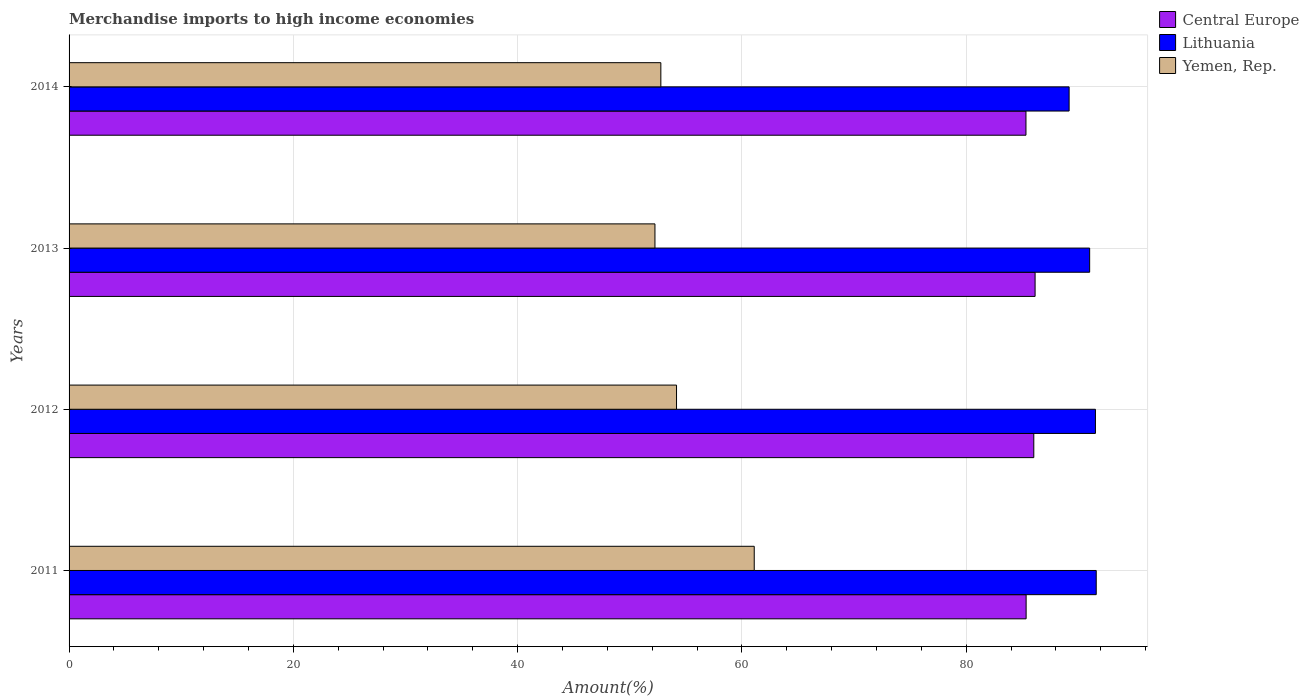How many different coloured bars are there?
Make the answer very short. 3. In how many cases, is the number of bars for a given year not equal to the number of legend labels?
Provide a short and direct response. 0. What is the percentage of amount earned from merchandise imports in Central Europe in 2013?
Your response must be concise. 86.14. Across all years, what is the maximum percentage of amount earned from merchandise imports in Lithuania?
Offer a very short reply. 91.59. Across all years, what is the minimum percentage of amount earned from merchandise imports in Lithuania?
Offer a terse response. 89.18. In which year was the percentage of amount earned from merchandise imports in Lithuania minimum?
Keep it short and to the point. 2014. What is the total percentage of amount earned from merchandise imports in Central Europe in the graph?
Your answer should be very brief. 342.84. What is the difference between the percentage of amount earned from merchandise imports in Yemen, Rep. in 2011 and that in 2012?
Ensure brevity in your answer.  6.93. What is the difference between the percentage of amount earned from merchandise imports in Yemen, Rep. in 2011 and the percentage of amount earned from merchandise imports in Central Europe in 2012?
Your answer should be very brief. -24.93. What is the average percentage of amount earned from merchandise imports in Yemen, Rep. per year?
Your answer should be very brief. 55.07. In the year 2011, what is the difference between the percentage of amount earned from merchandise imports in Yemen, Rep. and percentage of amount earned from merchandise imports in Lithuania?
Keep it short and to the point. -30.5. In how many years, is the percentage of amount earned from merchandise imports in Lithuania greater than 28 %?
Offer a very short reply. 4. What is the ratio of the percentage of amount earned from merchandise imports in Yemen, Rep. in 2012 to that in 2013?
Offer a very short reply. 1.04. What is the difference between the highest and the second highest percentage of amount earned from merchandise imports in Central Europe?
Offer a very short reply. 0.12. What is the difference between the highest and the lowest percentage of amount earned from merchandise imports in Lithuania?
Your answer should be very brief. 2.42. What does the 1st bar from the top in 2013 represents?
Ensure brevity in your answer.  Yemen, Rep. What does the 1st bar from the bottom in 2011 represents?
Your answer should be very brief. Central Europe. Is it the case that in every year, the sum of the percentage of amount earned from merchandise imports in Lithuania and percentage of amount earned from merchandise imports in Yemen, Rep. is greater than the percentage of amount earned from merchandise imports in Central Europe?
Offer a terse response. Yes. Are all the bars in the graph horizontal?
Your answer should be very brief. Yes. How many years are there in the graph?
Give a very brief answer. 4. Does the graph contain grids?
Give a very brief answer. Yes. How many legend labels are there?
Your response must be concise. 3. What is the title of the graph?
Give a very brief answer. Merchandise imports to high income economies. Does "Nicaragua" appear as one of the legend labels in the graph?
Offer a very short reply. No. What is the label or title of the X-axis?
Make the answer very short. Amount(%). What is the label or title of the Y-axis?
Your answer should be very brief. Years. What is the Amount(%) in Central Europe in 2011?
Your answer should be very brief. 85.34. What is the Amount(%) of Lithuania in 2011?
Your answer should be compact. 91.59. What is the Amount(%) in Yemen, Rep. in 2011?
Your answer should be compact. 61.1. What is the Amount(%) in Central Europe in 2012?
Your response must be concise. 86.03. What is the Amount(%) of Lithuania in 2012?
Make the answer very short. 91.52. What is the Amount(%) of Yemen, Rep. in 2012?
Your response must be concise. 54.17. What is the Amount(%) in Central Europe in 2013?
Offer a very short reply. 86.14. What is the Amount(%) in Lithuania in 2013?
Your answer should be compact. 91.01. What is the Amount(%) of Yemen, Rep. in 2013?
Ensure brevity in your answer.  52.24. What is the Amount(%) of Central Europe in 2014?
Provide a short and direct response. 85.33. What is the Amount(%) in Lithuania in 2014?
Your response must be concise. 89.18. What is the Amount(%) of Yemen, Rep. in 2014?
Offer a terse response. 52.77. Across all years, what is the maximum Amount(%) in Central Europe?
Offer a very short reply. 86.14. Across all years, what is the maximum Amount(%) of Lithuania?
Keep it short and to the point. 91.59. Across all years, what is the maximum Amount(%) in Yemen, Rep.?
Your response must be concise. 61.1. Across all years, what is the minimum Amount(%) of Central Europe?
Your answer should be compact. 85.33. Across all years, what is the minimum Amount(%) of Lithuania?
Your response must be concise. 89.18. Across all years, what is the minimum Amount(%) in Yemen, Rep.?
Offer a very short reply. 52.24. What is the total Amount(%) of Central Europe in the graph?
Give a very brief answer. 342.84. What is the total Amount(%) of Lithuania in the graph?
Keep it short and to the point. 363.3. What is the total Amount(%) in Yemen, Rep. in the graph?
Ensure brevity in your answer.  220.28. What is the difference between the Amount(%) of Central Europe in 2011 and that in 2012?
Offer a very short reply. -0.68. What is the difference between the Amount(%) in Lithuania in 2011 and that in 2012?
Offer a terse response. 0.07. What is the difference between the Amount(%) of Yemen, Rep. in 2011 and that in 2012?
Your response must be concise. 6.93. What is the difference between the Amount(%) of Central Europe in 2011 and that in 2013?
Offer a very short reply. -0.8. What is the difference between the Amount(%) in Lithuania in 2011 and that in 2013?
Offer a terse response. 0.59. What is the difference between the Amount(%) of Yemen, Rep. in 2011 and that in 2013?
Give a very brief answer. 8.85. What is the difference between the Amount(%) of Central Europe in 2011 and that in 2014?
Provide a succinct answer. 0.01. What is the difference between the Amount(%) of Lithuania in 2011 and that in 2014?
Make the answer very short. 2.42. What is the difference between the Amount(%) in Yemen, Rep. in 2011 and that in 2014?
Ensure brevity in your answer.  8.33. What is the difference between the Amount(%) in Central Europe in 2012 and that in 2013?
Ensure brevity in your answer.  -0.12. What is the difference between the Amount(%) in Lithuania in 2012 and that in 2013?
Your response must be concise. 0.51. What is the difference between the Amount(%) of Yemen, Rep. in 2012 and that in 2013?
Offer a terse response. 1.92. What is the difference between the Amount(%) of Central Europe in 2012 and that in 2014?
Your response must be concise. 0.7. What is the difference between the Amount(%) in Lithuania in 2012 and that in 2014?
Make the answer very short. 2.35. What is the difference between the Amount(%) in Yemen, Rep. in 2012 and that in 2014?
Ensure brevity in your answer.  1.4. What is the difference between the Amount(%) in Central Europe in 2013 and that in 2014?
Keep it short and to the point. 0.81. What is the difference between the Amount(%) of Lithuania in 2013 and that in 2014?
Provide a succinct answer. 1.83. What is the difference between the Amount(%) of Yemen, Rep. in 2013 and that in 2014?
Keep it short and to the point. -0.53. What is the difference between the Amount(%) of Central Europe in 2011 and the Amount(%) of Lithuania in 2012?
Ensure brevity in your answer.  -6.18. What is the difference between the Amount(%) in Central Europe in 2011 and the Amount(%) in Yemen, Rep. in 2012?
Make the answer very short. 31.18. What is the difference between the Amount(%) of Lithuania in 2011 and the Amount(%) of Yemen, Rep. in 2012?
Provide a short and direct response. 37.43. What is the difference between the Amount(%) in Central Europe in 2011 and the Amount(%) in Lithuania in 2013?
Keep it short and to the point. -5.67. What is the difference between the Amount(%) of Central Europe in 2011 and the Amount(%) of Yemen, Rep. in 2013?
Provide a succinct answer. 33.1. What is the difference between the Amount(%) of Lithuania in 2011 and the Amount(%) of Yemen, Rep. in 2013?
Make the answer very short. 39.35. What is the difference between the Amount(%) in Central Europe in 2011 and the Amount(%) in Lithuania in 2014?
Provide a succinct answer. -3.83. What is the difference between the Amount(%) in Central Europe in 2011 and the Amount(%) in Yemen, Rep. in 2014?
Make the answer very short. 32.57. What is the difference between the Amount(%) of Lithuania in 2011 and the Amount(%) of Yemen, Rep. in 2014?
Make the answer very short. 38.82. What is the difference between the Amount(%) of Central Europe in 2012 and the Amount(%) of Lithuania in 2013?
Your answer should be compact. -4.98. What is the difference between the Amount(%) in Central Europe in 2012 and the Amount(%) in Yemen, Rep. in 2013?
Keep it short and to the point. 33.78. What is the difference between the Amount(%) of Lithuania in 2012 and the Amount(%) of Yemen, Rep. in 2013?
Provide a short and direct response. 39.28. What is the difference between the Amount(%) of Central Europe in 2012 and the Amount(%) of Lithuania in 2014?
Keep it short and to the point. -3.15. What is the difference between the Amount(%) of Central Europe in 2012 and the Amount(%) of Yemen, Rep. in 2014?
Make the answer very short. 33.26. What is the difference between the Amount(%) of Lithuania in 2012 and the Amount(%) of Yemen, Rep. in 2014?
Give a very brief answer. 38.75. What is the difference between the Amount(%) in Central Europe in 2013 and the Amount(%) in Lithuania in 2014?
Make the answer very short. -3.03. What is the difference between the Amount(%) in Central Europe in 2013 and the Amount(%) in Yemen, Rep. in 2014?
Offer a very short reply. 33.37. What is the difference between the Amount(%) in Lithuania in 2013 and the Amount(%) in Yemen, Rep. in 2014?
Your answer should be very brief. 38.24. What is the average Amount(%) in Central Europe per year?
Make the answer very short. 85.71. What is the average Amount(%) of Lithuania per year?
Offer a terse response. 90.83. What is the average Amount(%) of Yemen, Rep. per year?
Your answer should be compact. 55.07. In the year 2011, what is the difference between the Amount(%) in Central Europe and Amount(%) in Lithuania?
Provide a short and direct response. -6.25. In the year 2011, what is the difference between the Amount(%) in Central Europe and Amount(%) in Yemen, Rep.?
Provide a short and direct response. 24.25. In the year 2011, what is the difference between the Amount(%) of Lithuania and Amount(%) of Yemen, Rep.?
Provide a short and direct response. 30.5. In the year 2012, what is the difference between the Amount(%) in Central Europe and Amount(%) in Lithuania?
Your answer should be compact. -5.5. In the year 2012, what is the difference between the Amount(%) in Central Europe and Amount(%) in Yemen, Rep.?
Ensure brevity in your answer.  31.86. In the year 2012, what is the difference between the Amount(%) in Lithuania and Amount(%) in Yemen, Rep.?
Your answer should be compact. 37.35. In the year 2013, what is the difference between the Amount(%) of Central Europe and Amount(%) of Lithuania?
Give a very brief answer. -4.87. In the year 2013, what is the difference between the Amount(%) in Central Europe and Amount(%) in Yemen, Rep.?
Your answer should be compact. 33.9. In the year 2013, what is the difference between the Amount(%) in Lithuania and Amount(%) in Yemen, Rep.?
Your response must be concise. 38.76. In the year 2014, what is the difference between the Amount(%) of Central Europe and Amount(%) of Lithuania?
Provide a succinct answer. -3.85. In the year 2014, what is the difference between the Amount(%) in Central Europe and Amount(%) in Yemen, Rep.?
Provide a short and direct response. 32.56. In the year 2014, what is the difference between the Amount(%) of Lithuania and Amount(%) of Yemen, Rep.?
Offer a terse response. 36.41. What is the ratio of the Amount(%) of Central Europe in 2011 to that in 2012?
Provide a succinct answer. 0.99. What is the ratio of the Amount(%) in Yemen, Rep. in 2011 to that in 2012?
Make the answer very short. 1.13. What is the ratio of the Amount(%) in Central Europe in 2011 to that in 2013?
Make the answer very short. 0.99. What is the ratio of the Amount(%) in Lithuania in 2011 to that in 2013?
Keep it short and to the point. 1.01. What is the ratio of the Amount(%) of Yemen, Rep. in 2011 to that in 2013?
Keep it short and to the point. 1.17. What is the ratio of the Amount(%) of Central Europe in 2011 to that in 2014?
Your answer should be very brief. 1. What is the ratio of the Amount(%) of Lithuania in 2011 to that in 2014?
Ensure brevity in your answer.  1.03. What is the ratio of the Amount(%) of Yemen, Rep. in 2011 to that in 2014?
Provide a short and direct response. 1.16. What is the ratio of the Amount(%) of Lithuania in 2012 to that in 2013?
Your answer should be very brief. 1.01. What is the ratio of the Amount(%) of Yemen, Rep. in 2012 to that in 2013?
Give a very brief answer. 1.04. What is the ratio of the Amount(%) of Central Europe in 2012 to that in 2014?
Your answer should be compact. 1.01. What is the ratio of the Amount(%) in Lithuania in 2012 to that in 2014?
Keep it short and to the point. 1.03. What is the ratio of the Amount(%) in Yemen, Rep. in 2012 to that in 2014?
Keep it short and to the point. 1.03. What is the ratio of the Amount(%) in Central Europe in 2013 to that in 2014?
Ensure brevity in your answer.  1.01. What is the ratio of the Amount(%) of Lithuania in 2013 to that in 2014?
Provide a succinct answer. 1.02. What is the difference between the highest and the second highest Amount(%) in Central Europe?
Your answer should be very brief. 0.12. What is the difference between the highest and the second highest Amount(%) of Lithuania?
Keep it short and to the point. 0.07. What is the difference between the highest and the second highest Amount(%) of Yemen, Rep.?
Your response must be concise. 6.93. What is the difference between the highest and the lowest Amount(%) of Central Europe?
Make the answer very short. 0.81. What is the difference between the highest and the lowest Amount(%) of Lithuania?
Offer a very short reply. 2.42. What is the difference between the highest and the lowest Amount(%) of Yemen, Rep.?
Ensure brevity in your answer.  8.85. 